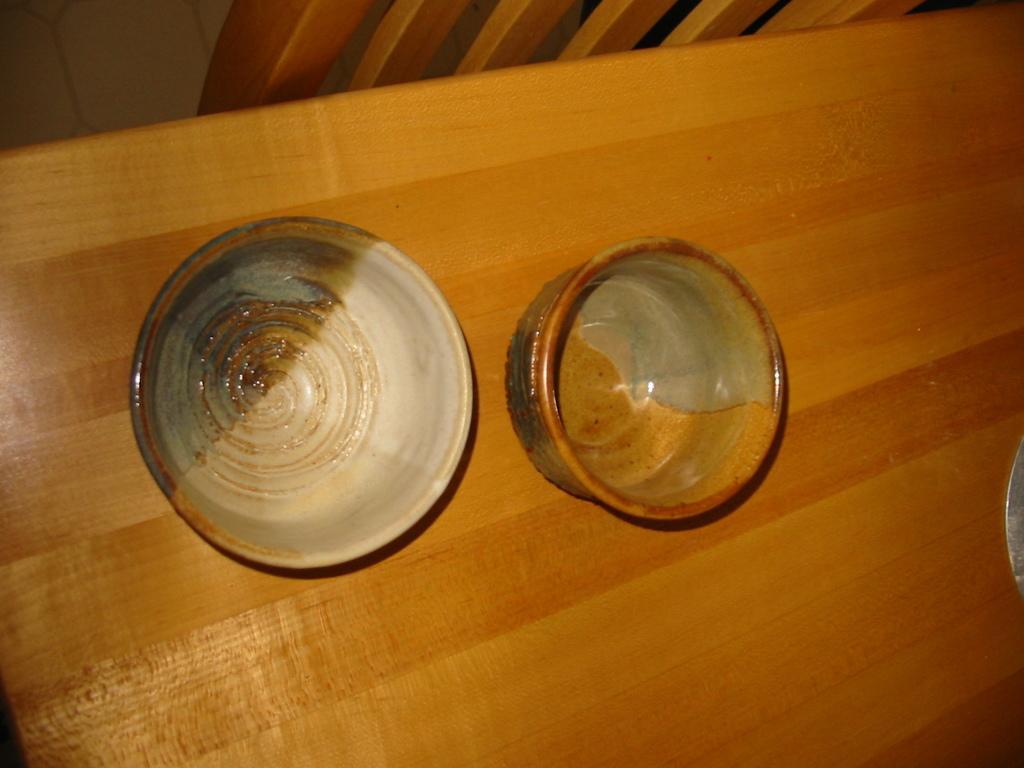How would you summarize this image in a sentence or two? In this image there are two porcelain bowls on a dining table. 